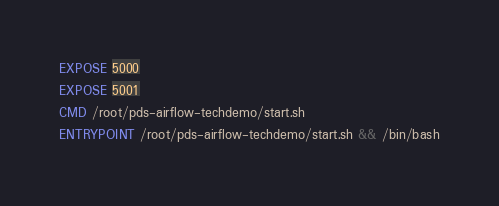<code> <loc_0><loc_0><loc_500><loc_500><_Dockerfile_>EXPOSE 5000
EXPOSE 5001
CMD /root/pds-airflow-techdemo/start.sh
ENTRYPOINT /root/pds-airflow-techdemo/start.sh && /bin/bash
</code> 